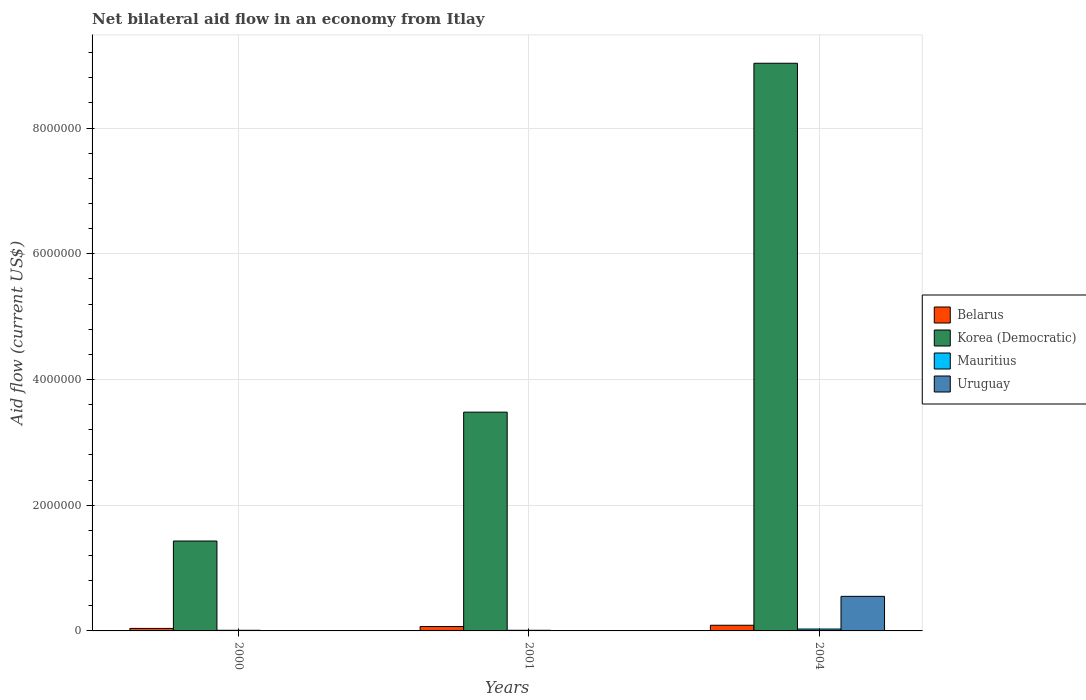How many groups of bars are there?
Ensure brevity in your answer.  3. Are the number of bars per tick equal to the number of legend labels?
Give a very brief answer. No. In how many cases, is the number of bars for a given year not equal to the number of legend labels?
Provide a succinct answer. 2. Across all years, what is the maximum net bilateral aid flow in Belarus?
Ensure brevity in your answer.  9.00e+04. Across all years, what is the minimum net bilateral aid flow in Belarus?
Ensure brevity in your answer.  4.00e+04. In which year was the net bilateral aid flow in Belarus maximum?
Offer a terse response. 2004. What is the total net bilateral aid flow in Mauritius in the graph?
Ensure brevity in your answer.  5.00e+04. What is the difference between the net bilateral aid flow in Belarus in 2000 and that in 2001?
Provide a short and direct response. -3.00e+04. What is the difference between the net bilateral aid flow in Korea (Democratic) in 2000 and the net bilateral aid flow in Belarus in 2004?
Your response must be concise. 1.34e+06. What is the average net bilateral aid flow in Uruguay per year?
Ensure brevity in your answer.  1.83e+05. In the year 2004, what is the difference between the net bilateral aid flow in Belarus and net bilateral aid flow in Korea (Democratic)?
Your answer should be compact. -8.94e+06. What is the ratio of the net bilateral aid flow in Korea (Democratic) in 2001 to that in 2004?
Give a very brief answer. 0.39. Is the net bilateral aid flow in Mauritius in 2001 less than that in 2004?
Ensure brevity in your answer.  Yes. Is the difference between the net bilateral aid flow in Belarus in 2001 and 2004 greater than the difference between the net bilateral aid flow in Korea (Democratic) in 2001 and 2004?
Give a very brief answer. Yes. What is the difference between the highest and the second highest net bilateral aid flow in Korea (Democratic)?
Give a very brief answer. 5.55e+06. Is it the case that in every year, the sum of the net bilateral aid flow in Belarus and net bilateral aid flow in Mauritius is greater than the net bilateral aid flow in Korea (Democratic)?
Ensure brevity in your answer.  No. How many bars are there?
Ensure brevity in your answer.  10. Are all the bars in the graph horizontal?
Your answer should be very brief. No. Does the graph contain any zero values?
Ensure brevity in your answer.  Yes. Where does the legend appear in the graph?
Provide a succinct answer. Center right. How are the legend labels stacked?
Offer a very short reply. Vertical. What is the title of the graph?
Make the answer very short. Net bilateral aid flow in an economy from Itlay. What is the Aid flow (current US$) in Belarus in 2000?
Offer a terse response. 4.00e+04. What is the Aid flow (current US$) in Korea (Democratic) in 2000?
Offer a very short reply. 1.43e+06. What is the Aid flow (current US$) in Mauritius in 2000?
Your answer should be very brief. 10000. What is the Aid flow (current US$) in Belarus in 2001?
Keep it short and to the point. 7.00e+04. What is the Aid flow (current US$) in Korea (Democratic) in 2001?
Ensure brevity in your answer.  3.48e+06. What is the Aid flow (current US$) of Mauritius in 2001?
Offer a terse response. 10000. What is the Aid flow (current US$) of Uruguay in 2001?
Give a very brief answer. 0. What is the Aid flow (current US$) in Belarus in 2004?
Ensure brevity in your answer.  9.00e+04. What is the Aid flow (current US$) of Korea (Democratic) in 2004?
Provide a short and direct response. 9.03e+06. What is the Aid flow (current US$) of Uruguay in 2004?
Keep it short and to the point. 5.50e+05. Across all years, what is the maximum Aid flow (current US$) of Belarus?
Your answer should be compact. 9.00e+04. Across all years, what is the maximum Aid flow (current US$) of Korea (Democratic)?
Offer a terse response. 9.03e+06. Across all years, what is the maximum Aid flow (current US$) in Mauritius?
Provide a short and direct response. 3.00e+04. Across all years, what is the minimum Aid flow (current US$) of Korea (Democratic)?
Your answer should be very brief. 1.43e+06. Across all years, what is the minimum Aid flow (current US$) in Mauritius?
Your answer should be very brief. 10000. What is the total Aid flow (current US$) of Korea (Democratic) in the graph?
Provide a short and direct response. 1.39e+07. What is the total Aid flow (current US$) of Mauritius in the graph?
Ensure brevity in your answer.  5.00e+04. What is the total Aid flow (current US$) in Uruguay in the graph?
Offer a very short reply. 5.50e+05. What is the difference between the Aid flow (current US$) of Belarus in 2000 and that in 2001?
Provide a succinct answer. -3.00e+04. What is the difference between the Aid flow (current US$) in Korea (Democratic) in 2000 and that in 2001?
Your answer should be very brief. -2.05e+06. What is the difference between the Aid flow (current US$) of Belarus in 2000 and that in 2004?
Your answer should be very brief. -5.00e+04. What is the difference between the Aid flow (current US$) of Korea (Democratic) in 2000 and that in 2004?
Offer a terse response. -7.60e+06. What is the difference between the Aid flow (current US$) of Mauritius in 2000 and that in 2004?
Provide a succinct answer. -2.00e+04. What is the difference between the Aid flow (current US$) of Belarus in 2001 and that in 2004?
Make the answer very short. -2.00e+04. What is the difference between the Aid flow (current US$) of Korea (Democratic) in 2001 and that in 2004?
Your response must be concise. -5.55e+06. What is the difference between the Aid flow (current US$) of Mauritius in 2001 and that in 2004?
Your answer should be compact. -2.00e+04. What is the difference between the Aid flow (current US$) in Belarus in 2000 and the Aid flow (current US$) in Korea (Democratic) in 2001?
Provide a succinct answer. -3.44e+06. What is the difference between the Aid flow (current US$) of Belarus in 2000 and the Aid flow (current US$) of Mauritius in 2001?
Your response must be concise. 3.00e+04. What is the difference between the Aid flow (current US$) in Korea (Democratic) in 2000 and the Aid flow (current US$) in Mauritius in 2001?
Provide a short and direct response. 1.42e+06. What is the difference between the Aid flow (current US$) of Belarus in 2000 and the Aid flow (current US$) of Korea (Democratic) in 2004?
Provide a succinct answer. -8.99e+06. What is the difference between the Aid flow (current US$) in Belarus in 2000 and the Aid flow (current US$) in Mauritius in 2004?
Make the answer very short. 10000. What is the difference between the Aid flow (current US$) in Belarus in 2000 and the Aid flow (current US$) in Uruguay in 2004?
Offer a very short reply. -5.10e+05. What is the difference between the Aid flow (current US$) in Korea (Democratic) in 2000 and the Aid flow (current US$) in Mauritius in 2004?
Your answer should be compact. 1.40e+06. What is the difference between the Aid flow (current US$) of Korea (Democratic) in 2000 and the Aid flow (current US$) of Uruguay in 2004?
Your answer should be very brief. 8.80e+05. What is the difference between the Aid flow (current US$) of Mauritius in 2000 and the Aid flow (current US$) of Uruguay in 2004?
Give a very brief answer. -5.40e+05. What is the difference between the Aid flow (current US$) in Belarus in 2001 and the Aid flow (current US$) in Korea (Democratic) in 2004?
Your answer should be compact. -8.96e+06. What is the difference between the Aid flow (current US$) of Belarus in 2001 and the Aid flow (current US$) of Uruguay in 2004?
Provide a short and direct response. -4.80e+05. What is the difference between the Aid flow (current US$) in Korea (Democratic) in 2001 and the Aid flow (current US$) in Mauritius in 2004?
Provide a succinct answer. 3.45e+06. What is the difference between the Aid flow (current US$) of Korea (Democratic) in 2001 and the Aid flow (current US$) of Uruguay in 2004?
Your response must be concise. 2.93e+06. What is the difference between the Aid flow (current US$) in Mauritius in 2001 and the Aid flow (current US$) in Uruguay in 2004?
Ensure brevity in your answer.  -5.40e+05. What is the average Aid flow (current US$) in Belarus per year?
Ensure brevity in your answer.  6.67e+04. What is the average Aid flow (current US$) in Korea (Democratic) per year?
Offer a very short reply. 4.65e+06. What is the average Aid flow (current US$) of Mauritius per year?
Your answer should be very brief. 1.67e+04. What is the average Aid flow (current US$) in Uruguay per year?
Keep it short and to the point. 1.83e+05. In the year 2000, what is the difference between the Aid flow (current US$) in Belarus and Aid flow (current US$) in Korea (Democratic)?
Give a very brief answer. -1.39e+06. In the year 2000, what is the difference between the Aid flow (current US$) in Belarus and Aid flow (current US$) in Mauritius?
Offer a very short reply. 3.00e+04. In the year 2000, what is the difference between the Aid flow (current US$) of Korea (Democratic) and Aid flow (current US$) of Mauritius?
Provide a short and direct response. 1.42e+06. In the year 2001, what is the difference between the Aid flow (current US$) of Belarus and Aid flow (current US$) of Korea (Democratic)?
Give a very brief answer. -3.41e+06. In the year 2001, what is the difference between the Aid flow (current US$) of Belarus and Aid flow (current US$) of Mauritius?
Offer a very short reply. 6.00e+04. In the year 2001, what is the difference between the Aid flow (current US$) of Korea (Democratic) and Aid flow (current US$) of Mauritius?
Provide a succinct answer. 3.47e+06. In the year 2004, what is the difference between the Aid flow (current US$) in Belarus and Aid flow (current US$) in Korea (Democratic)?
Your response must be concise. -8.94e+06. In the year 2004, what is the difference between the Aid flow (current US$) of Belarus and Aid flow (current US$) of Uruguay?
Offer a terse response. -4.60e+05. In the year 2004, what is the difference between the Aid flow (current US$) of Korea (Democratic) and Aid flow (current US$) of Mauritius?
Keep it short and to the point. 9.00e+06. In the year 2004, what is the difference between the Aid flow (current US$) of Korea (Democratic) and Aid flow (current US$) of Uruguay?
Provide a succinct answer. 8.48e+06. In the year 2004, what is the difference between the Aid flow (current US$) of Mauritius and Aid flow (current US$) of Uruguay?
Provide a succinct answer. -5.20e+05. What is the ratio of the Aid flow (current US$) in Korea (Democratic) in 2000 to that in 2001?
Ensure brevity in your answer.  0.41. What is the ratio of the Aid flow (current US$) in Belarus in 2000 to that in 2004?
Your response must be concise. 0.44. What is the ratio of the Aid flow (current US$) in Korea (Democratic) in 2000 to that in 2004?
Offer a terse response. 0.16. What is the ratio of the Aid flow (current US$) in Mauritius in 2000 to that in 2004?
Offer a very short reply. 0.33. What is the ratio of the Aid flow (current US$) in Belarus in 2001 to that in 2004?
Offer a terse response. 0.78. What is the ratio of the Aid flow (current US$) in Korea (Democratic) in 2001 to that in 2004?
Provide a short and direct response. 0.39. What is the ratio of the Aid flow (current US$) in Mauritius in 2001 to that in 2004?
Keep it short and to the point. 0.33. What is the difference between the highest and the second highest Aid flow (current US$) in Belarus?
Offer a very short reply. 2.00e+04. What is the difference between the highest and the second highest Aid flow (current US$) of Korea (Democratic)?
Offer a very short reply. 5.55e+06. What is the difference between the highest and the lowest Aid flow (current US$) in Belarus?
Offer a very short reply. 5.00e+04. What is the difference between the highest and the lowest Aid flow (current US$) in Korea (Democratic)?
Provide a short and direct response. 7.60e+06. 